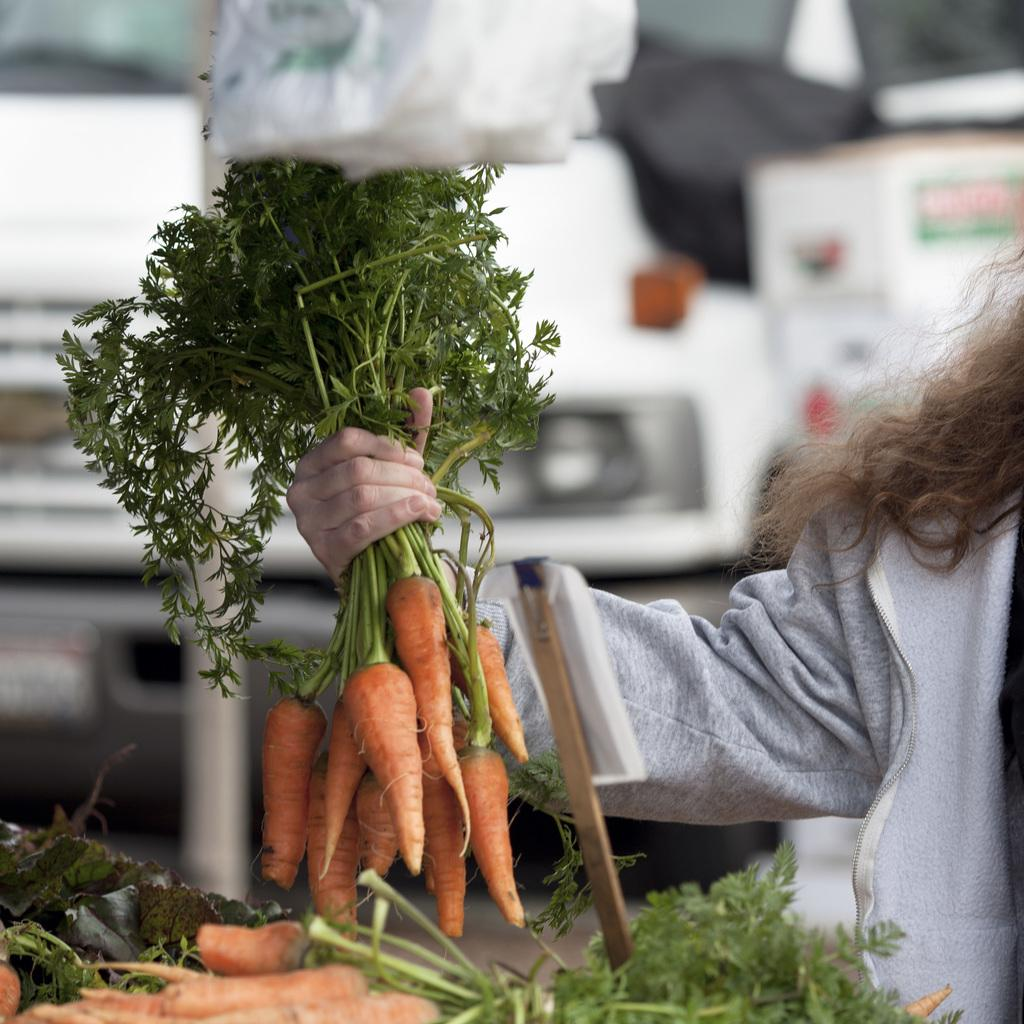What type of food item is visible in the image? There is a vegetable in the image. Where is the vegetable located in relation to the image? The vegetable is in the front of the image. Who is holding the vegetable in the image? A person is holding the vegetable in the image. Can you describe the background of the image? The background of the image is blurry. What type of milk is being poured onto the floor in the image? There is no milk or pouring action present in the image. Can you describe the dog's reaction to the vegetable in the image? There is no dog present in the image. 